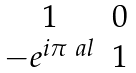<formula> <loc_0><loc_0><loc_500><loc_500>\begin{matrix} 1 & 0 \\ - e ^ { i \pi \ a l } & 1 \\ \end{matrix}</formula> 